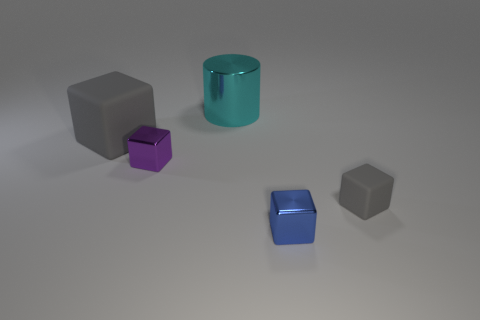What is the color of the cube that is the same size as the cyan shiny thing?
Offer a very short reply. Gray. How many gray things are rubber things or big rubber cubes?
Make the answer very short. 2. Are there more rubber cubes than small blocks?
Provide a short and direct response. No. Does the metal block that is on the left side of the cyan thing have the same size as the matte block that is in front of the big matte object?
Make the answer very short. Yes. What is the color of the metal object behind the tiny thing that is behind the gray matte thing that is in front of the large gray block?
Your answer should be very brief. Cyan. Are there any small gray rubber objects that have the same shape as the blue shiny object?
Your answer should be very brief. Yes. Are there more matte things on the right side of the small purple metallic cube than gray cylinders?
Give a very brief answer. Yes. How many matte objects are red spheres or tiny gray objects?
Your response must be concise. 1. There is a thing that is behind the small blue shiny object and right of the big cylinder; what is its size?
Provide a short and direct response. Small. Is there a tiny matte cube that is to the right of the matte object left of the big cyan shiny cylinder?
Give a very brief answer. Yes. 